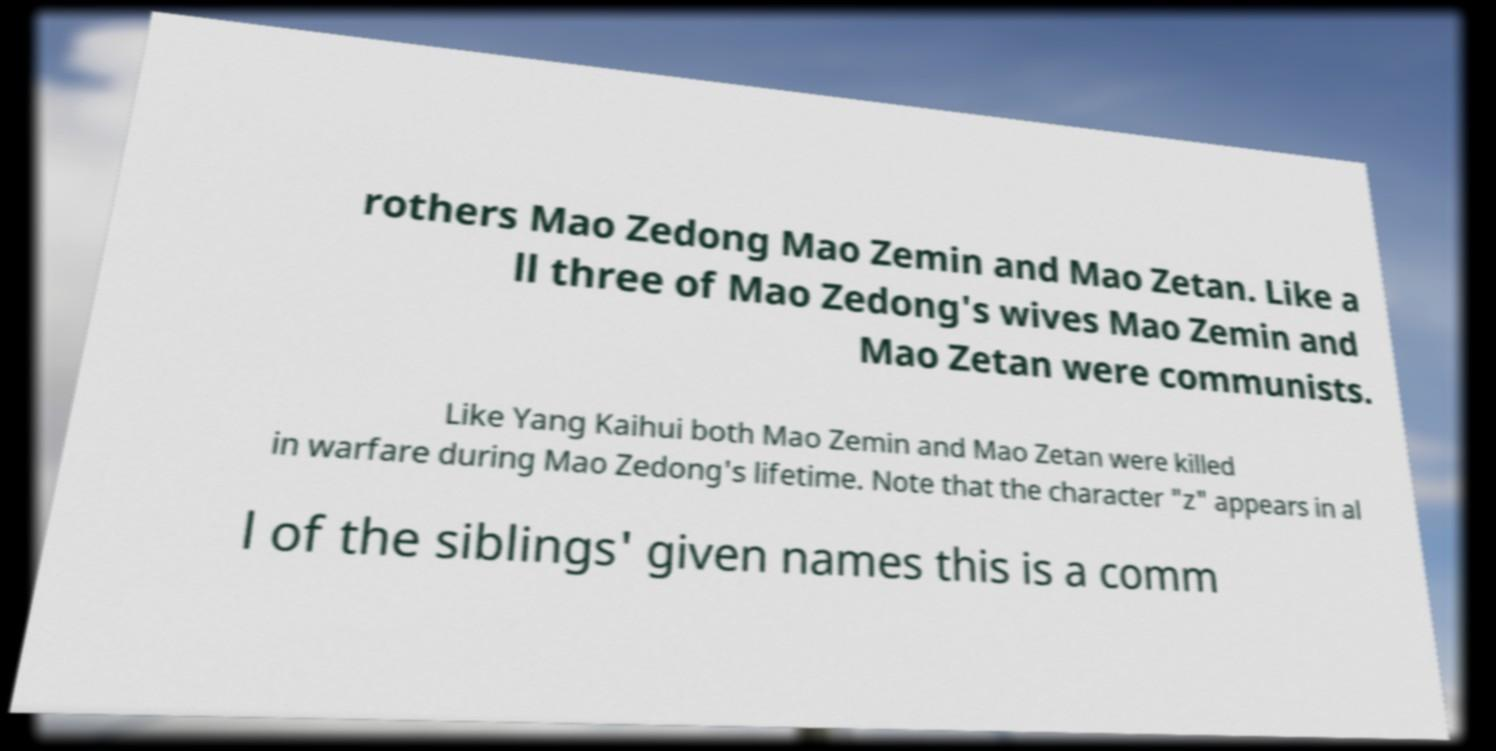I need the written content from this picture converted into text. Can you do that? rothers Mao Zedong Mao Zemin and Mao Zetan. Like a ll three of Mao Zedong's wives Mao Zemin and Mao Zetan were communists. Like Yang Kaihui both Mao Zemin and Mao Zetan were killed in warfare during Mao Zedong's lifetime. Note that the character "z" appears in al l of the siblings' given names this is a comm 